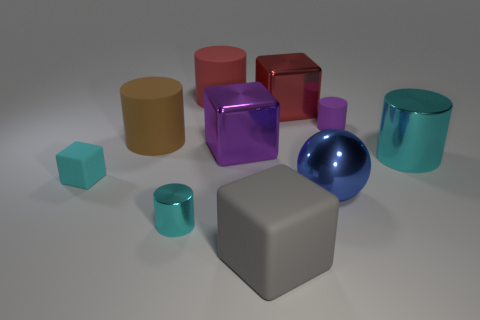Subtract all large red blocks. How many blocks are left? 3 Subtract all red cylinders. How many cylinders are left? 4 Add 2 big brown rubber cylinders. How many big brown rubber cylinders exist? 3 Subtract 0 yellow cylinders. How many objects are left? 10 Subtract all balls. How many objects are left? 9 Subtract 1 cylinders. How many cylinders are left? 4 Subtract all brown cylinders. Subtract all purple cubes. How many cylinders are left? 4 Subtract all cyan spheres. How many red cubes are left? 1 Subtract all small brown spheres. Subtract all large red rubber objects. How many objects are left? 9 Add 1 tiny matte cylinders. How many tiny matte cylinders are left? 2 